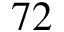<formula> <loc_0><loc_0><loc_500><loc_500>7 2</formula> 